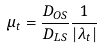Convert formula to latex. <formula><loc_0><loc_0><loc_500><loc_500>\mu _ { t } = \frac { D _ { O S } } { D _ { L S } } \frac { 1 } { | \lambda _ { t } | } \\</formula> 